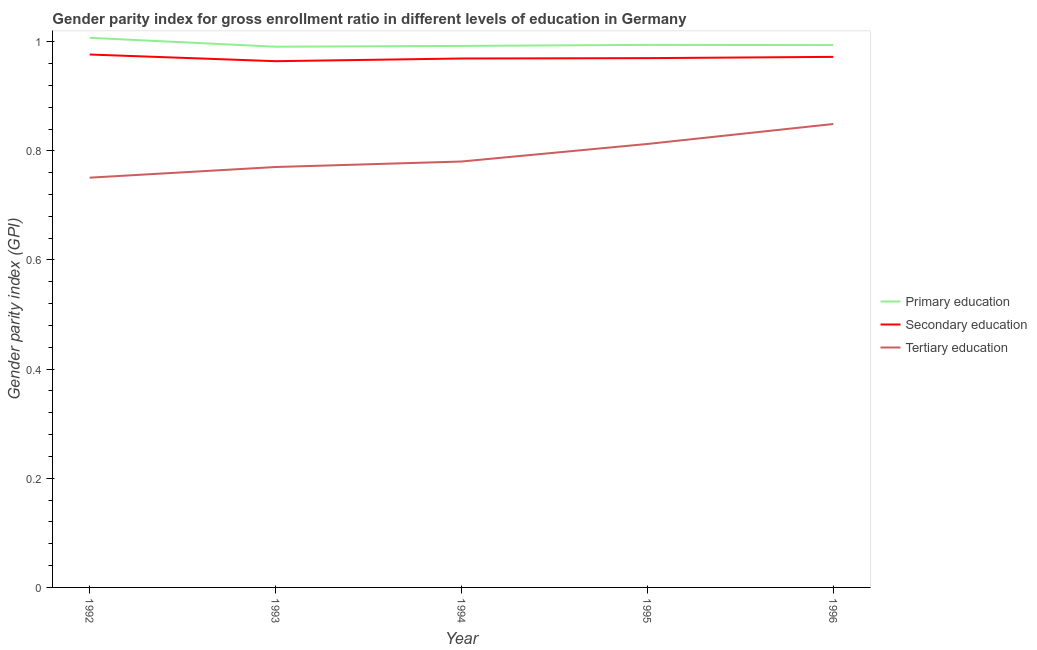How many different coloured lines are there?
Provide a succinct answer. 3. Does the line corresponding to gender parity index in primary education intersect with the line corresponding to gender parity index in secondary education?
Your response must be concise. No. Is the number of lines equal to the number of legend labels?
Your answer should be very brief. Yes. What is the gender parity index in secondary education in 1995?
Ensure brevity in your answer.  0.97. Across all years, what is the maximum gender parity index in primary education?
Offer a terse response. 1.01. Across all years, what is the minimum gender parity index in primary education?
Provide a short and direct response. 0.99. In which year was the gender parity index in secondary education minimum?
Make the answer very short. 1993. What is the total gender parity index in primary education in the graph?
Provide a succinct answer. 4.98. What is the difference between the gender parity index in secondary education in 1993 and that in 1996?
Provide a short and direct response. -0.01. What is the difference between the gender parity index in primary education in 1995 and the gender parity index in secondary education in 1994?
Offer a very short reply. 0.02. What is the average gender parity index in secondary education per year?
Provide a succinct answer. 0.97. In the year 1996, what is the difference between the gender parity index in tertiary education and gender parity index in secondary education?
Provide a short and direct response. -0.12. In how many years, is the gender parity index in primary education greater than 0.8?
Offer a very short reply. 5. What is the ratio of the gender parity index in primary education in 1994 to that in 1995?
Keep it short and to the point. 1. Is the gender parity index in tertiary education in 1993 less than that in 1995?
Your answer should be very brief. Yes. Is the difference between the gender parity index in primary education in 1992 and 1995 greater than the difference between the gender parity index in tertiary education in 1992 and 1995?
Give a very brief answer. Yes. What is the difference between the highest and the second highest gender parity index in tertiary education?
Provide a succinct answer. 0.04. What is the difference between the highest and the lowest gender parity index in primary education?
Make the answer very short. 0.02. How many lines are there?
Offer a very short reply. 3. How many years are there in the graph?
Provide a short and direct response. 5. What is the difference between two consecutive major ticks on the Y-axis?
Offer a very short reply. 0.2. Does the graph contain grids?
Your response must be concise. No. How many legend labels are there?
Your answer should be compact. 3. How are the legend labels stacked?
Make the answer very short. Vertical. What is the title of the graph?
Your response must be concise. Gender parity index for gross enrollment ratio in different levels of education in Germany. Does "Argument" appear as one of the legend labels in the graph?
Make the answer very short. No. What is the label or title of the X-axis?
Ensure brevity in your answer.  Year. What is the label or title of the Y-axis?
Ensure brevity in your answer.  Gender parity index (GPI). What is the Gender parity index (GPI) in Primary education in 1992?
Your response must be concise. 1.01. What is the Gender parity index (GPI) of Secondary education in 1992?
Give a very brief answer. 0.98. What is the Gender parity index (GPI) in Tertiary education in 1992?
Offer a terse response. 0.75. What is the Gender parity index (GPI) of Primary education in 1993?
Offer a terse response. 0.99. What is the Gender parity index (GPI) in Secondary education in 1993?
Your answer should be compact. 0.96. What is the Gender parity index (GPI) of Tertiary education in 1993?
Offer a very short reply. 0.77. What is the Gender parity index (GPI) of Primary education in 1994?
Keep it short and to the point. 0.99. What is the Gender parity index (GPI) in Secondary education in 1994?
Offer a very short reply. 0.97. What is the Gender parity index (GPI) in Tertiary education in 1994?
Ensure brevity in your answer.  0.78. What is the Gender parity index (GPI) of Primary education in 1995?
Your response must be concise. 0.99. What is the Gender parity index (GPI) in Secondary education in 1995?
Make the answer very short. 0.97. What is the Gender parity index (GPI) in Tertiary education in 1995?
Provide a short and direct response. 0.81. What is the Gender parity index (GPI) in Primary education in 1996?
Your answer should be compact. 0.99. What is the Gender parity index (GPI) of Secondary education in 1996?
Keep it short and to the point. 0.97. What is the Gender parity index (GPI) in Tertiary education in 1996?
Offer a terse response. 0.85. Across all years, what is the maximum Gender parity index (GPI) of Primary education?
Keep it short and to the point. 1.01. Across all years, what is the maximum Gender parity index (GPI) in Secondary education?
Your answer should be very brief. 0.98. Across all years, what is the maximum Gender parity index (GPI) in Tertiary education?
Your answer should be very brief. 0.85. Across all years, what is the minimum Gender parity index (GPI) in Primary education?
Keep it short and to the point. 0.99. Across all years, what is the minimum Gender parity index (GPI) of Secondary education?
Your answer should be very brief. 0.96. Across all years, what is the minimum Gender parity index (GPI) of Tertiary education?
Give a very brief answer. 0.75. What is the total Gender parity index (GPI) in Primary education in the graph?
Your answer should be very brief. 4.98. What is the total Gender parity index (GPI) of Secondary education in the graph?
Offer a terse response. 4.85. What is the total Gender parity index (GPI) in Tertiary education in the graph?
Keep it short and to the point. 3.96. What is the difference between the Gender parity index (GPI) in Primary education in 1992 and that in 1993?
Provide a short and direct response. 0.02. What is the difference between the Gender parity index (GPI) in Secondary education in 1992 and that in 1993?
Provide a succinct answer. 0.01. What is the difference between the Gender parity index (GPI) in Tertiary education in 1992 and that in 1993?
Provide a short and direct response. -0.02. What is the difference between the Gender parity index (GPI) in Primary education in 1992 and that in 1994?
Offer a terse response. 0.01. What is the difference between the Gender parity index (GPI) in Secondary education in 1992 and that in 1994?
Make the answer very short. 0.01. What is the difference between the Gender parity index (GPI) of Tertiary education in 1992 and that in 1994?
Your response must be concise. -0.03. What is the difference between the Gender parity index (GPI) in Primary education in 1992 and that in 1995?
Give a very brief answer. 0.01. What is the difference between the Gender parity index (GPI) of Secondary education in 1992 and that in 1995?
Offer a terse response. 0.01. What is the difference between the Gender parity index (GPI) in Tertiary education in 1992 and that in 1995?
Provide a short and direct response. -0.06. What is the difference between the Gender parity index (GPI) in Primary education in 1992 and that in 1996?
Your answer should be compact. 0.01. What is the difference between the Gender parity index (GPI) of Secondary education in 1992 and that in 1996?
Your response must be concise. 0. What is the difference between the Gender parity index (GPI) of Tertiary education in 1992 and that in 1996?
Provide a short and direct response. -0.1. What is the difference between the Gender parity index (GPI) in Primary education in 1993 and that in 1994?
Provide a succinct answer. -0. What is the difference between the Gender parity index (GPI) of Secondary education in 1993 and that in 1994?
Your answer should be compact. -0. What is the difference between the Gender parity index (GPI) in Tertiary education in 1993 and that in 1994?
Your response must be concise. -0.01. What is the difference between the Gender parity index (GPI) of Primary education in 1993 and that in 1995?
Offer a terse response. -0. What is the difference between the Gender parity index (GPI) of Secondary education in 1993 and that in 1995?
Offer a very short reply. -0.01. What is the difference between the Gender parity index (GPI) of Tertiary education in 1993 and that in 1995?
Your response must be concise. -0.04. What is the difference between the Gender parity index (GPI) in Primary education in 1993 and that in 1996?
Your answer should be very brief. -0. What is the difference between the Gender parity index (GPI) in Secondary education in 1993 and that in 1996?
Your answer should be very brief. -0.01. What is the difference between the Gender parity index (GPI) in Tertiary education in 1993 and that in 1996?
Keep it short and to the point. -0.08. What is the difference between the Gender parity index (GPI) in Primary education in 1994 and that in 1995?
Offer a terse response. -0. What is the difference between the Gender parity index (GPI) in Secondary education in 1994 and that in 1995?
Your answer should be very brief. -0. What is the difference between the Gender parity index (GPI) of Tertiary education in 1994 and that in 1995?
Your answer should be very brief. -0.03. What is the difference between the Gender parity index (GPI) in Primary education in 1994 and that in 1996?
Provide a succinct answer. -0. What is the difference between the Gender parity index (GPI) of Secondary education in 1994 and that in 1996?
Provide a succinct answer. -0. What is the difference between the Gender parity index (GPI) in Tertiary education in 1994 and that in 1996?
Your response must be concise. -0.07. What is the difference between the Gender parity index (GPI) of Primary education in 1995 and that in 1996?
Your response must be concise. 0. What is the difference between the Gender parity index (GPI) of Secondary education in 1995 and that in 1996?
Provide a short and direct response. -0. What is the difference between the Gender parity index (GPI) of Tertiary education in 1995 and that in 1996?
Make the answer very short. -0.04. What is the difference between the Gender parity index (GPI) in Primary education in 1992 and the Gender parity index (GPI) in Secondary education in 1993?
Your response must be concise. 0.04. What is the difference between the Gender parity index (GPI) in Primary education in 1992 and the Gender parity index (GPI) in Tertiary education in 1993?
Provide a short and direct response. 0.24. What is the difference between the Gender parity index (GPI) in Secondary education in 1992 and the Gender parity index (GPI) in Tertiary education in 1993?
Give a very brief answer. 0.21. What is the difference between the Gender parity index (GPI) in Primary education in 1992 and the Gender parity index (GPI) in Secondary education in 1994?
Your answer should be compact. 0.04. What is the difference between the Gender parity index (GPI) in Primary education in 1992 and the Gender parity index (GPI) in Tertiary education in 1994?
Provide a succinct answer. 0.23. What is the difference between the Gender parity index (GPI) of Secondary education in 1992 and the Gender parity index (GPI) of Tertiary education in 1994?
Offer a very short reply. 0.2. What is the difference between the Gender parity index (GPI) of Primary education in 1992 and the Gender parity index (GPI) of Secondary education in 1995?
Provide a succinct answer. 0.04. What is the difference between the Gender parity index (GPI) of Primary education in 1992 and the Gender parity index (GPI) of Tertiary education in 1995?
Provide a succinct answer. 0.19. What is the difference between the Gender parity index (GPI) of Secondary education in 1992 and the Gender parity index (GPI) of Tertiary education in 1995?
Make the answer very short. 0.16. What is the difference between the Gender parity index (GPI) in Primary education in 1992 and the Gender parity index (GPI) in Secondary education in 1996?
Keep it short and to the point. 0.03. What is the difference between the Gender parity index (GPI) in Primary education in 1992 and the Gender parity index (GPI) in Tertiary education in 1996?
Offer a terse response. 0.16. What is the difference between the Gender parity index (GPI) of Secondary education in 1992 and the Gender parity index (GPI) of Tertiary education in 1996?
Ensure brevity in your answer.  0.13. What is the difference between the Gender parity index (GPI) of Primary education in 1993 and the Gender parity index (GPI) of Secondary education in 1994?
Offer a very short reply. 0.02. What is the difference between the Gender parity index (GPI) in Primary education in 1993 and the Gender parity index (GPI) in Tertiary education in 1994?
Provide a short and direct response. 0.21. What is the difference between the Gender parity index (GPI) in Secondary education in 1993 and the Gender parity index (GPI) in Tertiary education in 1994?
Make the answer very short. 0.18. What is the difference between the Gender parity index (GPI) of Primary education in 1993 and the Gender parity index (GPI) of Secondary education in 1995?
Make the answer very short. 0.02. What is the difference between the Gender parity index (GPI) in Primary education in 1993 and the Gender parity index (GPI) in Tertiary education in 1995?
Provide a succinct answer. 0.18. What is the difference between the Gender parity index (GPI) of Secondary education in 1993 and the Gender parity index (GPI) of Tertiary education in 1995?
Keep it short and to the point. 0.15. What is the difference between the Gender parity index (GPI) of Primary education in 1993 and the Gender parity index (GPI) of Secondary education in 1996?
Your answer should be compact. 0.02. What is the difference between the Gender parity index (GPI) in Primary education in 1993 and the Gender parity index (GPI) in Tertiary education in 1996?
Offer a terse response. 0.14. What is the difference between the Gender parity index (GPI) of Secondary education in 1993 and the Gender parity index (GPI) of Tertiary education in 1996?
Your response must be concise. 0.12. What is the difference between the Gender parity index (GPI) in Primary education in 1994 and the Gender parity index (GPI) in Secondary education in 1995?
Provide a short and direct response. 0.02. What is the difference between the Gender parity index (GPI) of Primary education in 1994 and the Gender parity index (GPI) of Tertiary education in 1995?
Keep it short and to the point. 0.18. What is the difference between the Gender parity index (GPI) in Secondary education in 1994 and the Gender parity index (GPI) in Tertiary education in 1995?
Your response must be concise. 0.16. What is the difference between the Gender parity index (GPI) in Primary education in 1994 and the Gender parity index (GPI) in Secondary education in 1996?
Make the answer very short. 0.02. What is the difference between the Gender parity index (GPI) of Primary education in 1994 and the Gender parity index (GPI) of Tertiary education in 1996?
Offer a very short reply. 0.14. What is the difference between the Gender parity index (GPI) in Secondary education in 1994 and the Gender parity index (GPI) in Tertiary education in 1996?
Your response must be concise. 0.12. What is the difference between the Gender parity index (GPI) of Primary education in 1995 and the Gender parity index (GPI) of Secondary education in 1996?
Provide a short and direct response. 0.02. What is the difference between the Gender parity index (GPI) in Primary education in 1995 and the Gender parity index (GPI) in Tertiary education in 1996?
Your response must be concise. 0.14. What is the difference between the Gender parity index (GPI) in Secondary education in 1995 and the Gender parity index (GPI) in Tertiary education in 1996?
Give a very brief answer. 0.12. What is the average Gender parity index (GPI) in Secondary education per year?
Offer a very short reply. 0.97. What is the average Gender parity index (GPI) in Tertiary education per year?
Give a very brief answer. 0.79. In the year 1992, what is the difference between the Gender parity index (GPI) in Primary education and Gender parity index (GPI) in Secondary education?
Give a very brief answer. 0.03. In the year 1992, what is the difference between the Gender parity index (GPI) in Primary education and Gender parity index (GPI) in Tertiary education?
Make the answer very short. 0.26. In the year 1992, what is the difference between the Gender parity index (GPI) of Secondary education and Gender parity index (GPI) of Tertiary education?
Offer a terse response. 0.23. In the year 1993, what is the difference between the Gender parity index (GPI) in Primary education and Gender parity index (GPI) in Secondary education?
Provide a succinct answer. 0.03. In the year 1993, what is the difference between the Gender parity index (GPI) in Primary education and Gender parity index (GPI) in Tertiary education?
Offer a terse response. 0.22. In the year 1993, what is the difference between the Gender parity index (GPI) of Secondary education and Gender parity index (GPI) of Tertiary education?
Your answer should be very brief. 0.19. In the year 1994, what is the difference between the Gender parity index (GPI) in Primary education and Gender parity index (GPI) in Secondary education?
Your answer should be compact. 0.02. In the year 1994, what is the difference between the Gender parity index (GPI) of Primary education and Gender parity index (GPI) of Tertiary education?
Your response must be concise. 0.21. In the year 1994, what is the difference between the Gender parity index (GPI) in Secondary education and Gender parity index (GPI) in Tertiary education?
Your answer should be compact. 0.19. In the year 1995, what is the difference between the Gender parity index (GPI) in Primary education and Gender parity index (GPI) in Secondary education?
Offer a terse response. 0.02. In the year 1995, what is the difference between the Gender parity index (GPI) of Primary education and Gender parity index (GPI) of Tertiary education?
Offer a terse response. 0.18. In the year 1995, what is the difference between the Gender parity index (GPI) of Secondary education and Gender parity index (GPI) of Tertiary education?
Offer a terse response. 0.16. In the year 1996, what is the difference between the Gender parity index (GPI) of Primary education and Gender parity index (GPI) of Secondary education?
Keep it short and to the point. 0.02. In the year 1996, what is the difference between the Gender parity index (GPI) in Primary education and Gender parity index (GPI) in Tertiary education?
Make the answer very short. 0.14. In the year 1996, what is the difference between the Gender parity index (GPI) in Secondary education and Gender parity index (GPI) in Tertiary education?
Ensure brevity in your answer.  0.12. What is the ratio of the Gender parity index (GPI) of Primary education in 1992 to that in 1993?
Provide a short and direct response. 1.02. What is the ratio of the Gender parity index (GPI) in Secondary education in 1992 to that in 1993?
Your answer should be compact. 1.01. What is the ratio of the Gender parity index (GPI) in Tertiary education in 1992 to that in 1993?
Offer a very short reply. 0.97. What is the ratio of the Gender parity index (GPI) of Primary education in 1992 to that in 1994?
Offer a terse response. 1.01. What is the ratio of the Gender parity index (GPI) of Secondary education in 1992 to that in 1994?
Your answer should be compact. 1.01. What is the ratio of the Gender parity index (GPI) of Tertiary education in 1992 to that in 1994?
Provide a short and direct response. 0.96. What is the ratio of the Gender parity index (GPI) of Primary education in 1992 to that in 1995?
Offer a terse response. 1.01. What is the ratio of the Gender parity index (GPI) of Secondary education in 1992 to that in 1995?
Provide a short and direct response. 1.01. What is the ratio of the Gender parity index (GPI) of Tertiary education in 1992 to that in 1995?
Make the answer very short. 0.92. What is the ratio of the Gender parity index (GPI) of Primary education in 1992 to that in 1996?
Offer a very short reply. 1.01. What is the ratio of the Gender parity index (GPI) in Tertiary education in 1992 to that in 1996?
Give a very brief answer. 0.88. What is the ratio of the Gender parity index (GPI) in Primary education in 1993 to that in 1994?
Keep it short and to the point. 1. What is the ratio of the Gender parity index (GPI) in Tertiary education in 1993 to that in 1994?
Offer a very short reply. 0.99. What is the ratio of the Gender parity index (GPI) of Primary education in 1993 to that in 1995?
Provide a short and direct response. 1. What is the ratio of the Gender parity index (GPI) in Tertiary education in 1993 to that in 1995?
Ensure brevity in your answer.  0.95. What is the ratio of the Gender parity index (GPI) in Primary education in 1993 to that in 1996?
Make the answer very short. 1. What is the ratio of the Gender parity index (GPI) of Tertiary education in 1993 to that in 1996?
Ensure brevity in your answer.  0.91. What is the ratio of the Gender parity index (GPI) in Primary education in 1994 to that in 1995?
Give a very brief answer. 1. What is the ratio of the Gender parity index (GPI) of Secondary education in 1994 to that in 1995?
Keep it short and to the point. 1. What is the ratio of the Gender parity index (GPI) in Tertiary education in 1994 to that in 1995?
Your answer should be very brief. 0.96. What is the ratio of the Gender parity index (GPI) of Primary education in 1994 to that in 1996?
Ensure brevity in your answer.  1. What is the ratio of the Gender parity index (GPI) in Secondary education in 1994 to that in 1996?
Provide a short and direct response. 1. What is the ratio of the Gender parity index (GPI) of Tertiary education in 1994 to that in 1996?
Offer a very short reply. 0.92. What is the ratio of the Gender parity index (GPI) in Secondary education in 1995 to that in 1996?
Keep it short and to the point. 1. What is the ratio of the Gender parity index (GPI) of Tertiary education in 1995 to that in 1996?
Your response must be concise. 0.96. What is the difference between the highest and the second highest Gender parity index (GPI) in Primary education?
Your answer should be very brief. 0.01. What is the difference between the highest and the second highest Gender parity index (GPI) in Secondary education?
Make the answer very short. 0. What is the difference between the highest and the second highest Gender parity index (GPI) of Tertiary education?
Give a very brief answer. 0.04. What is the difference between the highest and the lowest Gender parity index (GPI) in Primary education?
Your answer should be very brief. 0.02. What is the difference between the highest and the lowest Gender parity index (GPI) in Secondary education?
Your answer should be very brief. 0.01. What is the difference between the highest and the lowest Gender parity index (GPI) of Tertiary education?
Offer a very short reply. 0.1. 